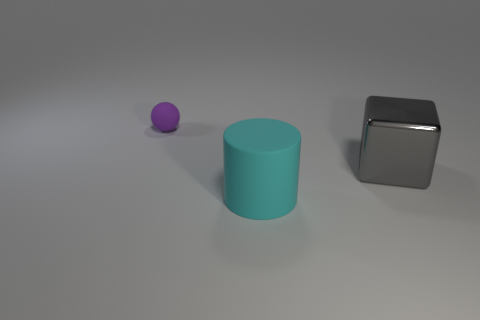Are there any other things that are the same material as the gray thing?
Make the answer very short. No. Is there any other thing that is the same size as the purple sphere?
Offer a terse response. No. There is a cyan thing to the left of the big gray cube; what is it made of?
Provide a short and direct response. Rubber. Are there any other things that have the same color as the block?
Make the answer very short. No. There is a cyan cylinder that is made of the same material as the small sphere; what is its size?
Give a very brief answer. Large. How many small things are either cyan cylinders or gray objects?
Make the answer very short. 0. How big is the rubber thing to the right of the matte object that is behind the thing in front of the large metal thing?
Make the answer very short. Large. How many other matte objects have the same size as the gray thing?
Offer a very short reply. 1. How many things are large gray blocks or large rubber cylinders in front of the gray thing?
Keep it short and to the point. 2. The big shiny thing has what shape?
Make the answer very short. Cube. 